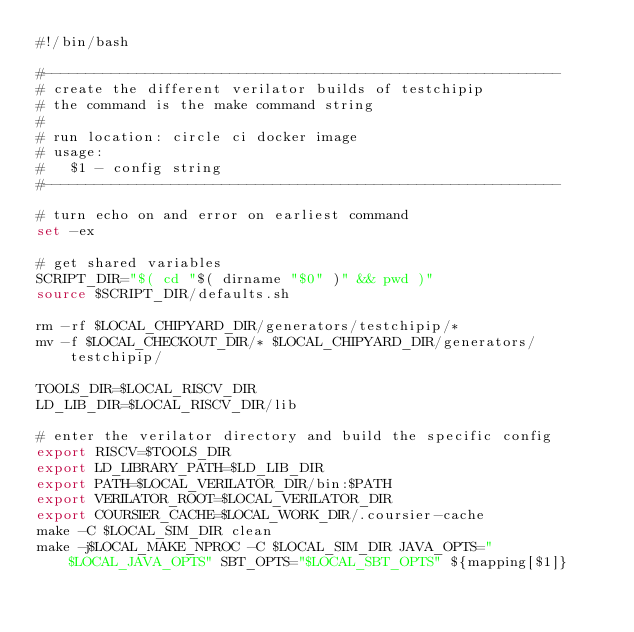Convert code to text. <code><loc_0><loc_0><loc_500><loc_500><_Bash_>#!/bin/bash

#-------------------------------------------------------------
# create the different verilator builds of testchipip
# the command is the make command string
#
# run location: circle ci docker image
# usage:
#   $1 - config string
#-------------------------------------------------------------

# turn echo on and error on earliest command
set -ex

# get shared variables
SCRIPT_DIR="$( cd "$( dirname "$0" )" && pwd )"
source $SCRIPT_DIR/defaults.sh

rm -rf $LOCAL_CHIPYARD_DIR/generators/testchipip/*
mv -f $LOCAL_CHECKOUT_DIR/* $LOCAL_CHIPYARD_DIR/generators/testchipip/

TOOLS_DIR=$LOCAL_RISCV_DIR
LD_LIB_DIR=$LOCAL_RISCV_DIR/lib

# enter the verilator directory and build the specific config
export RISCV=$TOOLS_DIR
export LD_LIBRARY_PATH=$LD_LIB_DIR
export PATH=$LOCAL_VERILATOR_DIR/bin:$PATH
export VERILATOR_ROOT=$LOCAL_VERILATOR_DIR
export COURSIER_CACHE=$LOCAL_WORK_DIR/.coursier-cache
make -C $LOCAL_SIM_DIR clean
make -j$LOCAL_MAKE_NPROC -C $LOCAL_SIM_DIR JAVA_OPTS="$LOCAL_JAVA_OPTS" SBT_OPTS="$LOCAL_SBT_OPTS" ${mapping[$1]}
</code> 